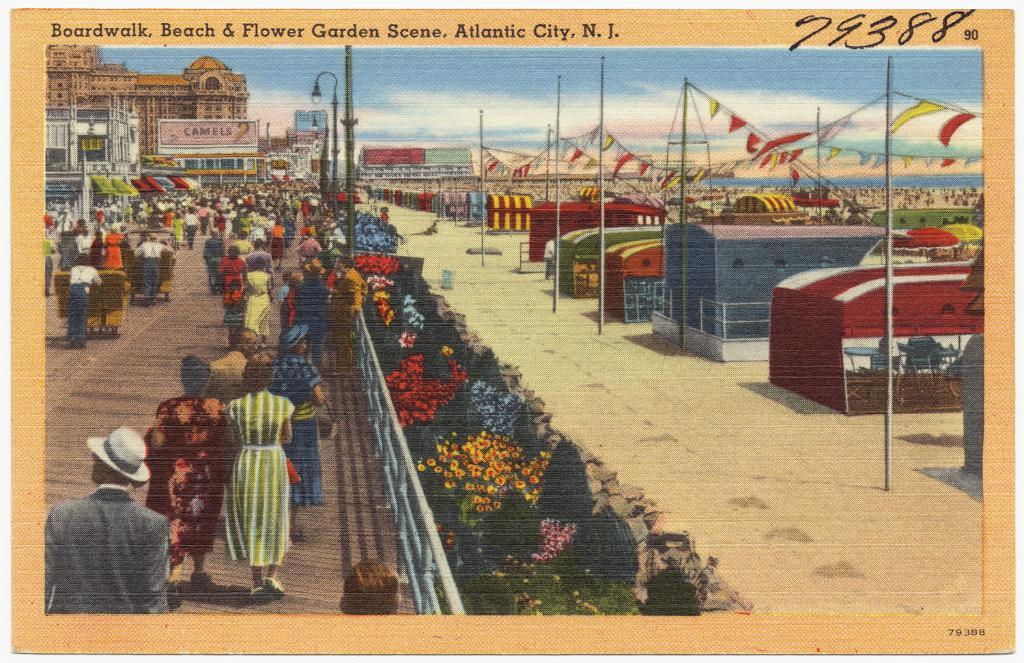<image>
Give a short and clear explanation of the subsequent image. a postcard with the numbers 79388 in the top right 